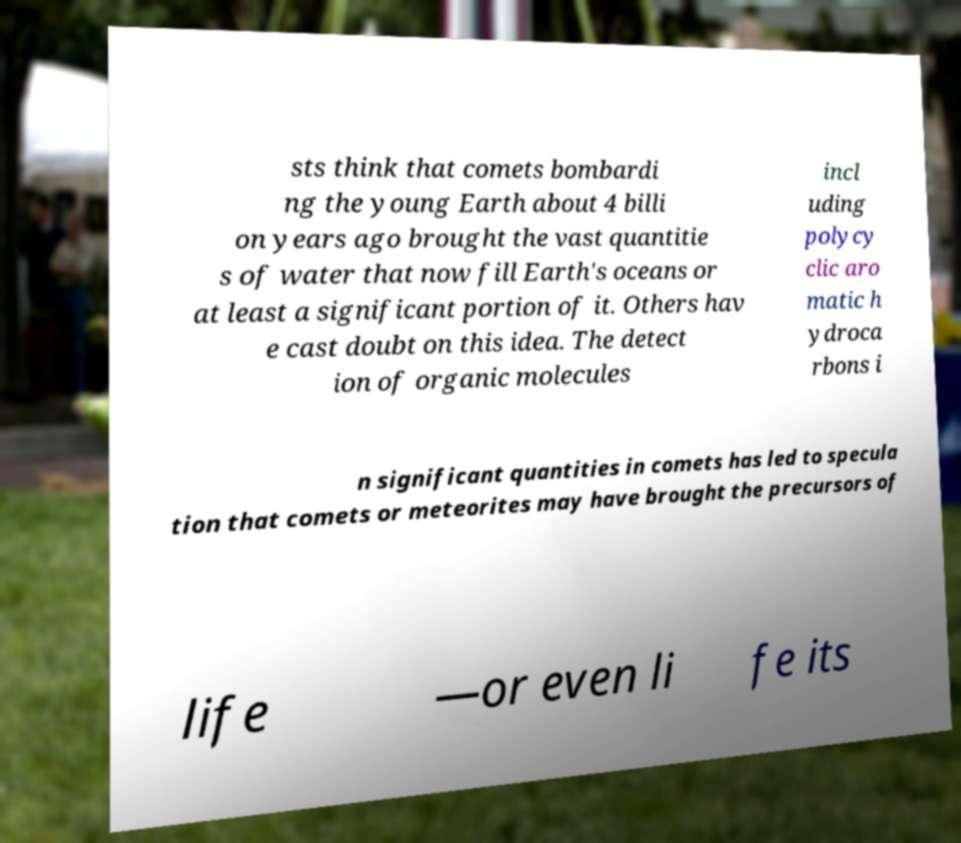Can you read and provide the text displayed in the image?This photo seems to have some interesting text. Can you extract and type it out for me? sts think that comets bombardi ng the young Earth about 4 billi on years ago brought the vast quantitie s of water that now fill Earth's oceans or at least a significant portion of it. Others hav e cast doubt on this idea. The detect ion of organic molecules incl uding polycy clic aro matic h ydroca rbons i n significant quantities in comets has led to specula tion that comets or meteorites may have brought the precursors of life —or even li fe its 